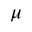Convert formula to latex. <formula><loc_0><loc_0><loc_500><loc_500>\mu</formula> 